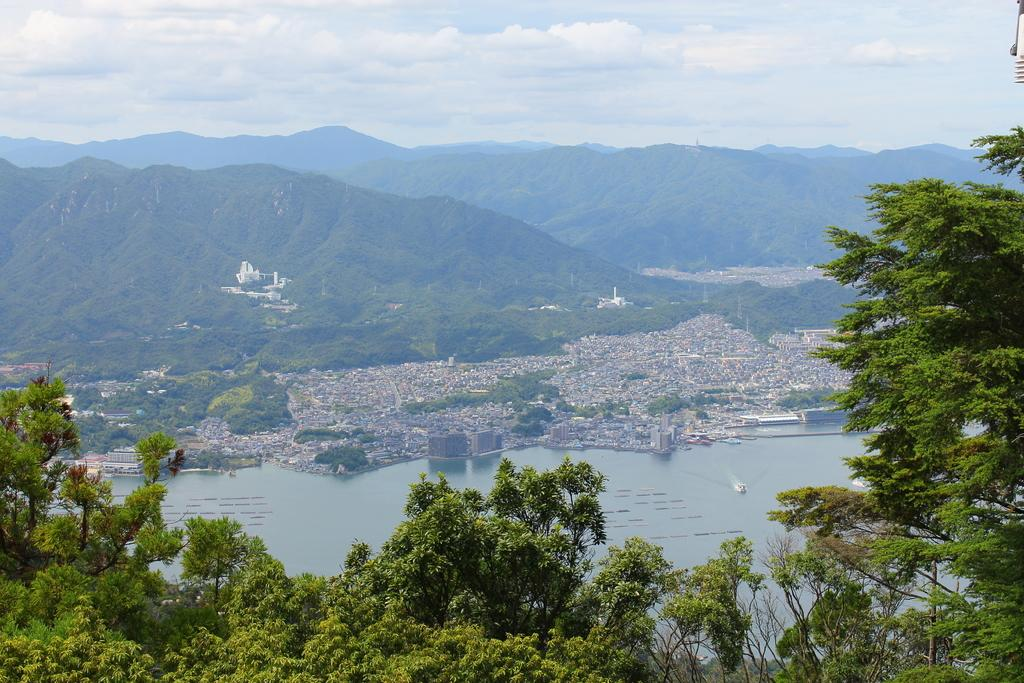What type of natural elements can be seen in the image? There are trees in the image. What type of man-made structures are present in the image? There are buildings in the image. What type of geographical features can be seen in the image? There are hills in the image. What type of transportation is depicted on the water in the image? There are boats on the water in the image. What is visible in the sky at the top of the image? There are clouds in the sky at the top of the image. What type of fruit is being used to express disgust in the image? There is no fruit present in the image, nor is there any expression of disgust. 